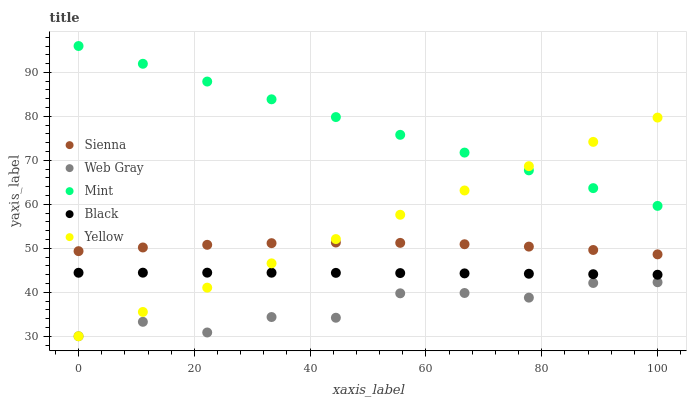Does Web Gray have the minimum area under the curve?
Answer yes or no. Yes. Does Mint have the maximum area under the curve?
Answer yes or no. Yes. Does Black have the minimum area under the curve?
Answer yes or no. No. Does Black have the maximum area under the curve?
Answer yes or no. No. Is Yellow the smoothest?
Answer yes or no. Yes. Is Web Gray the roughest?
Answer yes or no. Yes. Is Black the smoothest?
Answer yes or no. No. Is Black the roughest?
Answer yes or no. No. Does Web Gray have the lowest value?
Answer yes or no. Yes. Does Black have the lowest value?
Answer yes or no. No. Does Mint have the highest value?
Answer yes or no. Yes. Does Black have the highest value?
Answer yes or no. No. Is Web Gray less than Black?
Answer yes or no. Yes. Is Mint greater than Sienna?
Answer yes or no. Yes. Does Yellow intersect Black?
Answer yes or no. Yes. Is Yellow less than Black?
Answer yes or no. No. Is Yellow greater than Black?
Answer yes or no. No. Does Web Gray intersect Black?
Answer yes or no. No. 